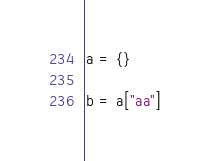Convert code to text. <code><loc_0><loc_0><loc_500><loc_500><_Python_>a = {}

b = a["aa"]</code> 